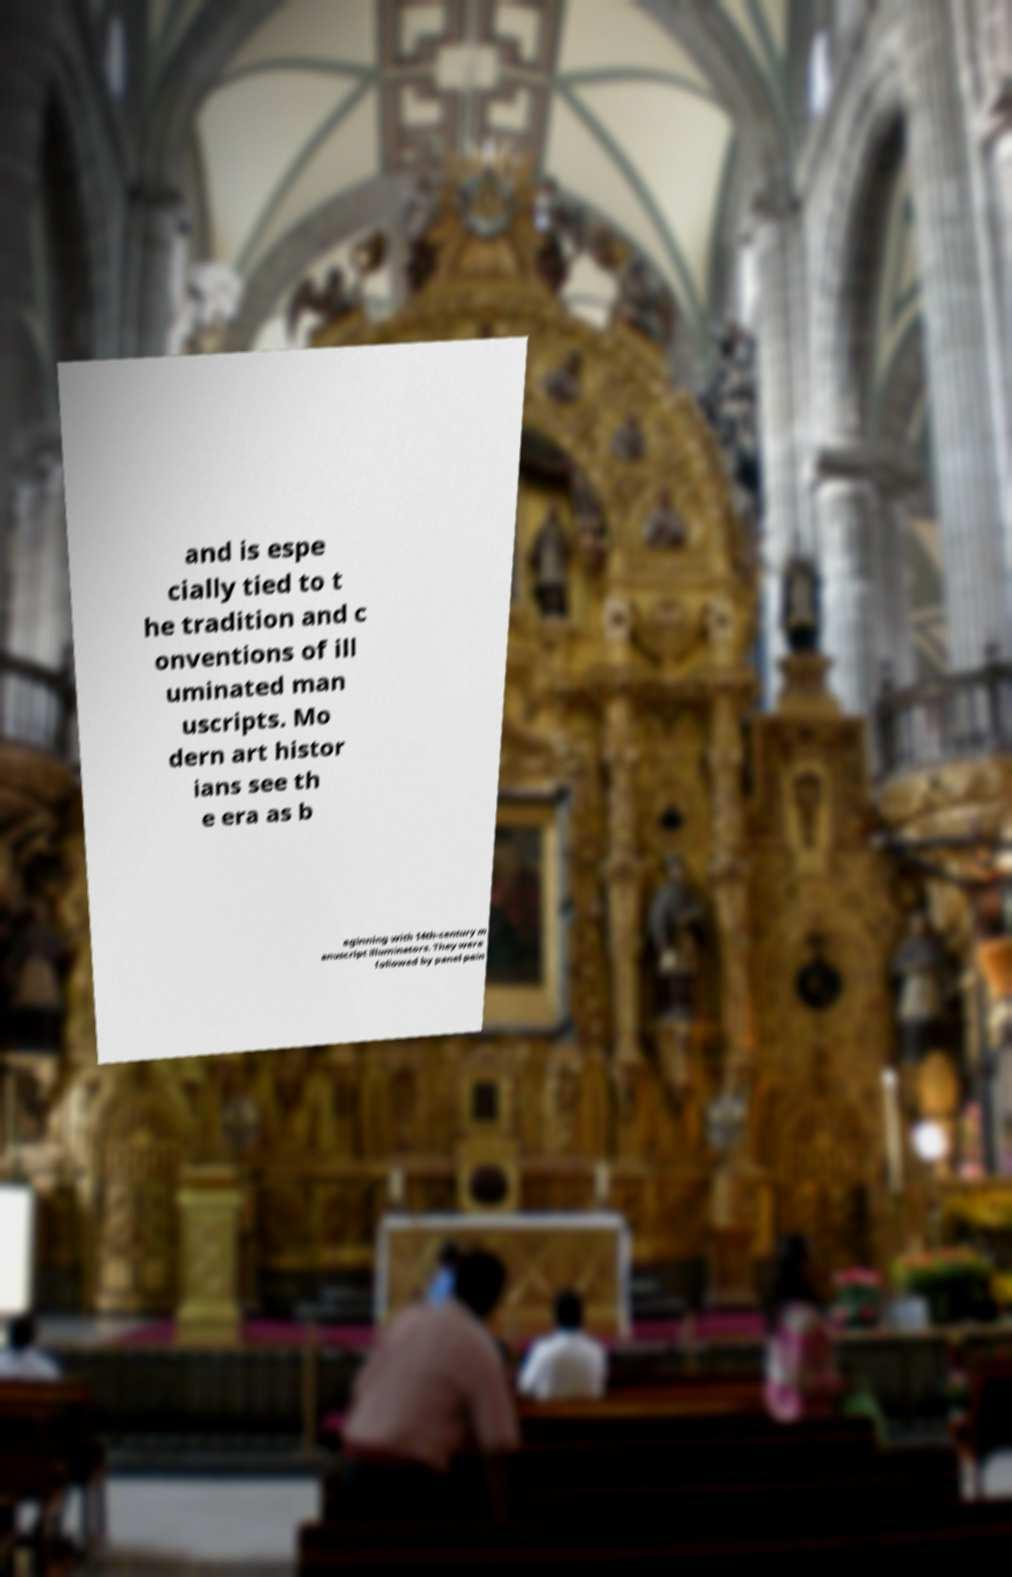Please read and relay the text visible in this image. What does it say? and is espe cially tied to t he tradition and c onventions of ill uminated man uscripts. Mo dern art histor ians see th e era as b eginning with 14th-century m anuscript illuminators. They were followed by panel pain 